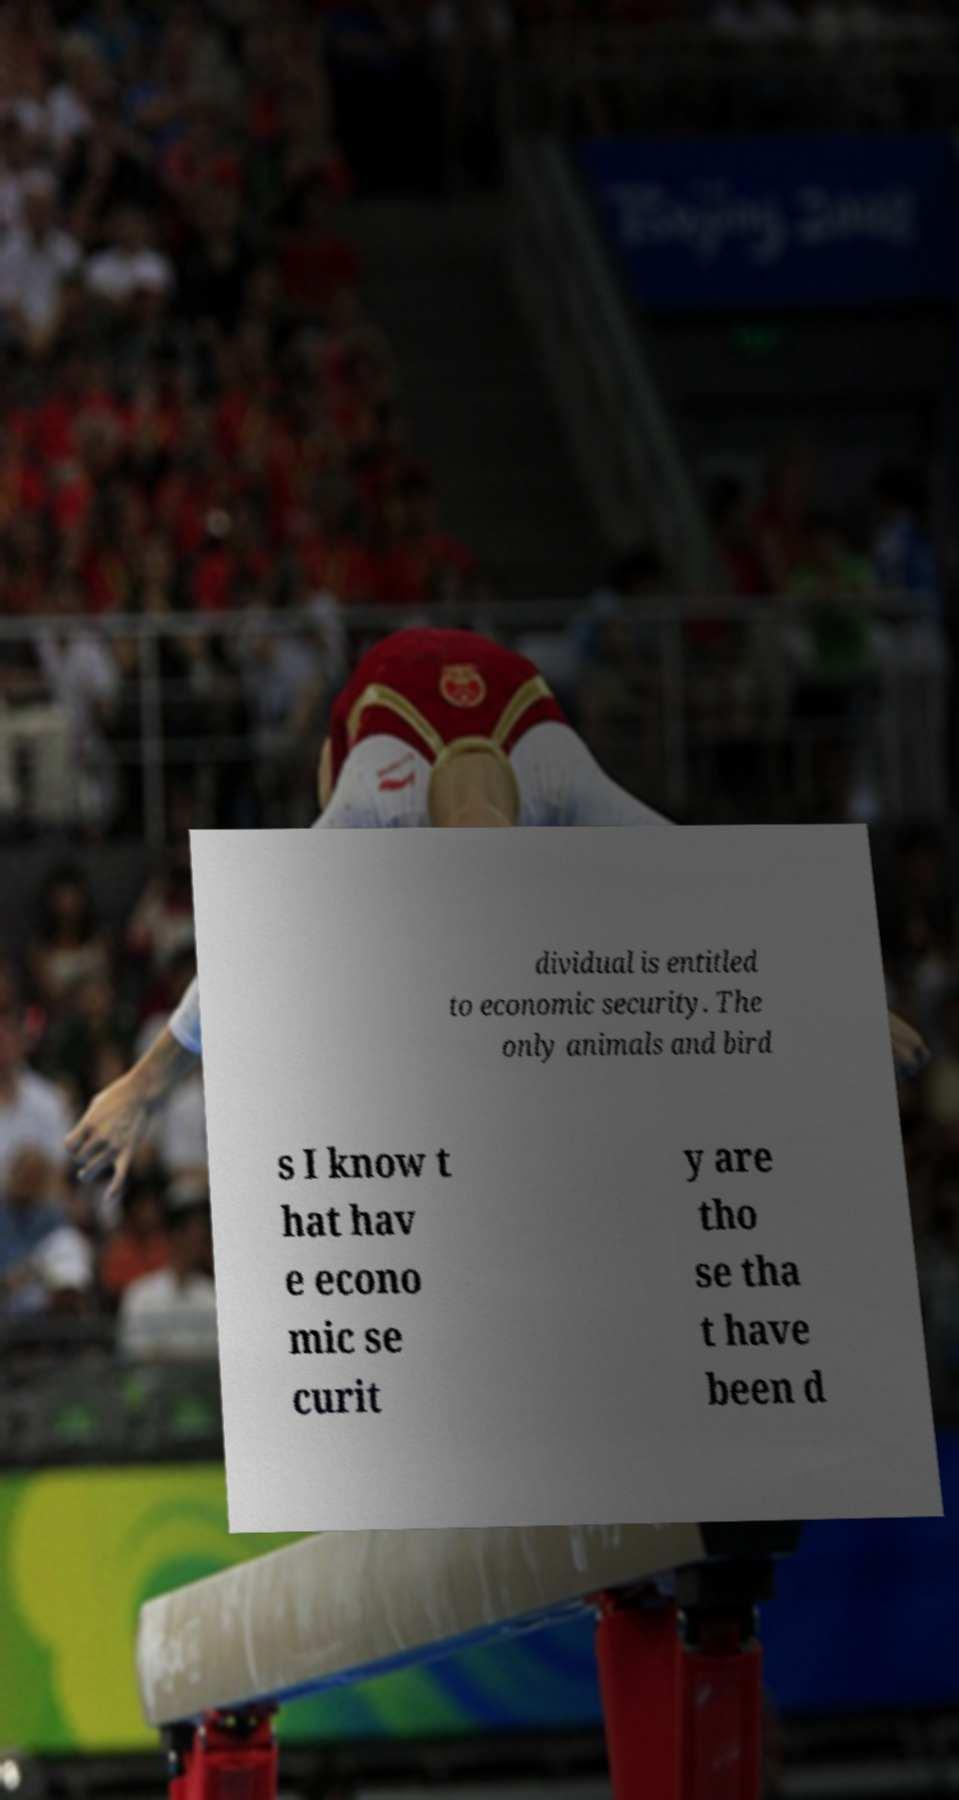Please read and relay the text visible in this image. What does it say? dividual is entitled to economic security. The only animals and bird s I know t hat hav e econo mic se curit y are tho se tha t have been d 